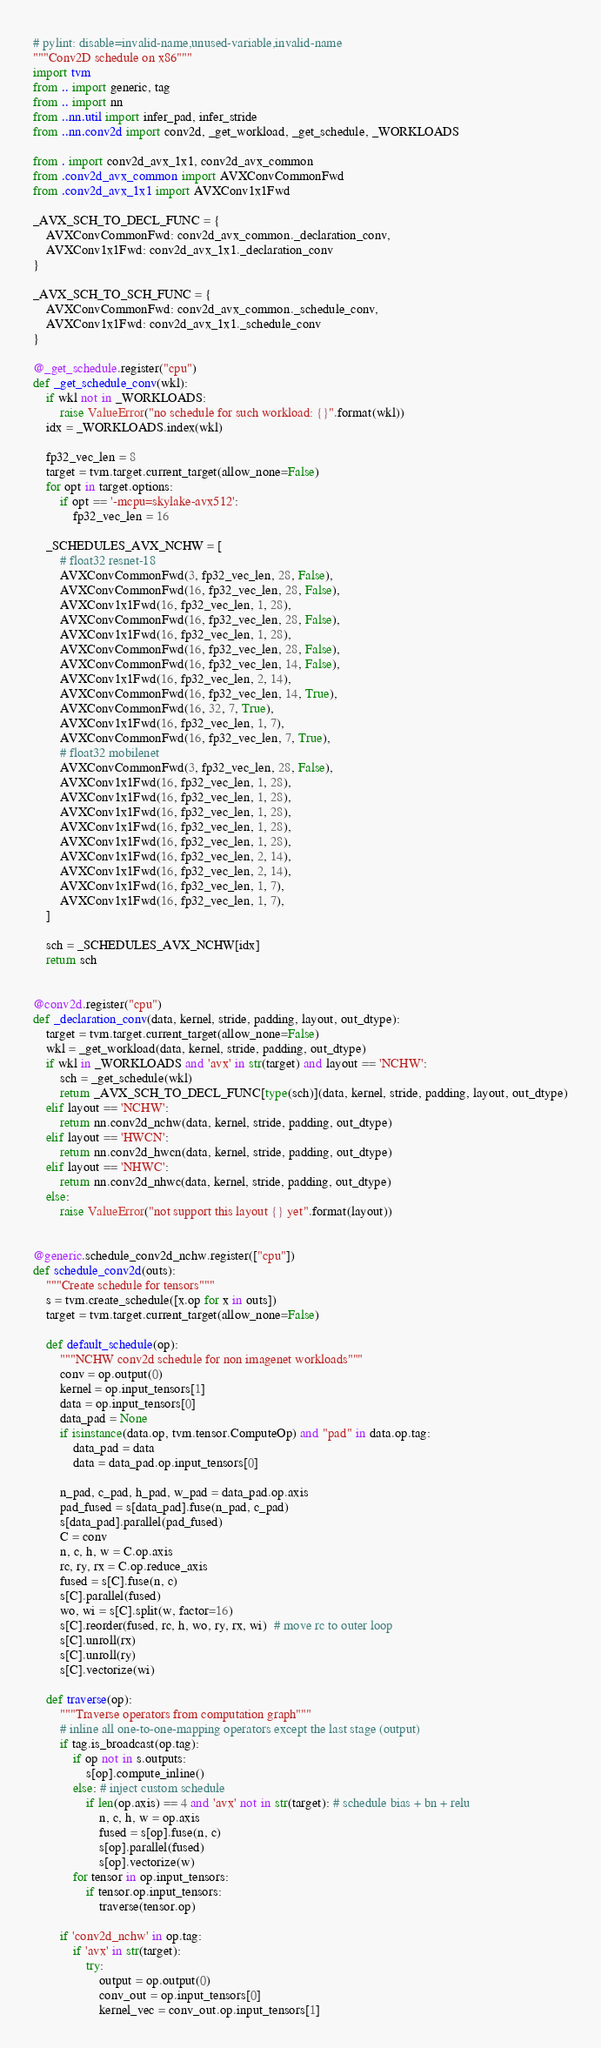<code> <loc_0><loc_0><loc_500><loc_500><_Python_># pylint: disable=invalid-name,unused-variable,invalid-name
"""Conv2D schedule on x86"""
import tvm
from .. import generic, tag
from .. import nn
from ..nn.util import infer_pad, infer_stride
from ..nn.conv2d import conv2d, _get_workload, _get_schedule, _WORKLOADS

from . import conv2d_avx_1x1, conv2d_avx_common
from .conv2d_avx_common import AVXConvCommonFwd
from .conv2d_avx_1x1 import AVXConv1x1Fwd

_AVX_SCH_TO_DECL_FUNC = {
    AVXConvCommonFwd: conv2d_avx_common._declaration_conv,
    AVXConv1x1Fwd: conv2d_avx_1x1._declaration_conv
}

_AVX_SCH_TO_SCH_FUNC = {
    AVXConvCommonFwd: conv2d_avx_common._schedule_conv,
    AVXConv1x1Fwd: conv2d_avx_1x1._schedule_conv
}

@_get_schedule.register("cpu")
def _get_schedule_conv(wkl):
    if wkl not in _WORKLOADS:
        raise ValueError("no schedule for such workload: {}".format(wkl))
    idx = _WORKLOADS.index(wkl)

    fp32_vec_len = 8
    target = tvm.target.current_target(allow_none=False)
    for opt in target.options:
        if opt == '-mcpu=skylake-avx512':
            fp32_vec_len = 16

    _SCHEDULES_AVX_NCHW = [
        # float32 resnet-18
        AVXConvCommonFwd(3, fp32_vec_len, 28, False),
        AVXConvCommonFwd(16, fp32_vec_len, 28, False),
        AVXConv1x1Fwd(16, fp32_vec_len, 1, 28),
        AVXConvCommonFwd(16, fp32_vec_len, 28, False),
        AVXConv1x1Fwd(16, fp32_vec_len, 1, 28),
        AVXConvCommonFwd(16, fp32_vec_len, 28, False),
        AVXConvCommonFwd(16, fp32_vec_len, 14, False),
        AVXConv1x1Fwd(16, fp32_vec_len, 2, 14),
        AVXConvCommonFwd(16, fp32_vec_len, 14, True),
        AVXConvCommonFwd(16, 32, 7, True),
        AVXConv1x1Fwd(16, fp32_vec_len, 1, 7),
        AVXConvCommonFwd(16, fp32_vec_len, 7, True),
        # float32 mobilenet
        AVXConvCommonFwd(3, fp32_vec_len, 28, False),
        AVXConv1x1Fwd(16, fp32_vec_len, 1, 28),
        AVXConv1x1Fwd(16, fp32_vec_len, 1, 28),
        AVXConv1x1Fwd(16, fp32_vec_len, 1, 28),
        AVXConv1x1Fwd(16, fp32_vec_len, 1, 28),
        AVXConv1x1Fwd(16, fp32_vec_len, 1, 28),
        AVXConv1x1Fwd(16, fp32_vec_len, 2, 14),
        AVXConv1x1Fwd(16, fp32_vec_len, 2, 14),
        AVXConv1x1Fwd(16, fp32_vec_len, 1, 7),
        AVXConv1x1Fwd(16, fp32_vec_len, 1, 7),
    ]

    sch = _SCHEDULES_AVX_NCHW[idx]
    return sch


@conv2d.register("cpu")
def _declaration_conv(data, kernel, stride, padding, layout, out_dtype):
    target = tvm.target.current_target(allow_none=False)
    wkl = _get_workload(data, kernel, stride, padding, out_dtype)
    if wkl in _WORKLOADS and 'avx' in str(target) and layout == 'NCHW':
        sch = _get_schedule(wkl)
        return _AVX_SCH_TO_DECL_FUNC[type(sch)](data, kernel, stride, padding, layout, out_dtype)
    elif layout == 'NCHW':
        return nn.conv2d_nchw(data, kernel, stride, padding, out_dtype)
    elif layout == 'HWCN':
        return nn.conv2d_hwcn(data, kernel, stride, padding, out_dtype)
    elif layout == 'NHWC':
        return nn.conv2d_nhwc(data, kernel, stride, padding, out_dtype)
    else:
        raise ValueError("not support this layout {} yet".format(layout))


@generic.schedule_conv2d_nchw.register(["cpu"])
def schedule_conv2d(outs):
    """Create schedule for tensors"""
    s = tvm.create_schedule([x.op for x in outs])
    target = tvm.target.current_target(allow_none=False)

    def default_schedule(op):
        """NCHW conv2d schedule for non imagenet workloads"""
        conv = op.output(0)
        kernel = op.input_tensors[1]
        data = op.input_tensors[0]
        data_pad = None
        if isinstance(data.op, tvm.tensor.ComputeOp) and "pad" in data.op.tag:
            data_pad = data
            data = data_pad.op.input_tensors[0]

        n_pad, c_pad, h_pad, w_pad = data_pad.op.axis
        pad_fused = s[data_pad].fuse(n_pad, c_pad)
        s[data_pad].parallel(pad_fused)
        C = conv
        n, c, h, w = C.op.axis
        rc, ry, rx = C.op.reduce_axis
        fused = s[C].fuse(n, c)
        s[C].parallel(fused)
        wo, wi = s[C].split(w, factor=16)
        s[C].reorder(fused, rc, h, wo, ry, rx, wi)  # move rc to outer loop
        s[C].unroll(rx)
        s[C].unroll(ry)
        s[C].vectorize(wi)

    def traverse(op):
        """Traverse operators from computation graph"""
        # inline all one-to-one-mapping operators except the last stage (output)
        if tag.is_broadcast(op.tag):
            if op not in s.outputs:
                s[op].compute_inline()
            else: # inject custom schedule
                if len(op.axis) == 4 and 'avx' not in str(target): # schedule bias + bn + relu
                    n, c, h, w = op.axis
                    fused = s[op].fuse(n, c)
                    s[op].parallel(fused)
                    s[op].vectorize(w)
            for tensor in op.input_tensors:
                if tensor.op.input_tensors:
                    traverse(tensor.op)

        if 'conv2d_nchw' in op.tag:
            if 'avx' in str(target):
                try:
                    output = op.output(0)
                    conv_out = op.input_tensors[0]
                    kernel_vec = conv_out.op.input_tensors[1]</code> 